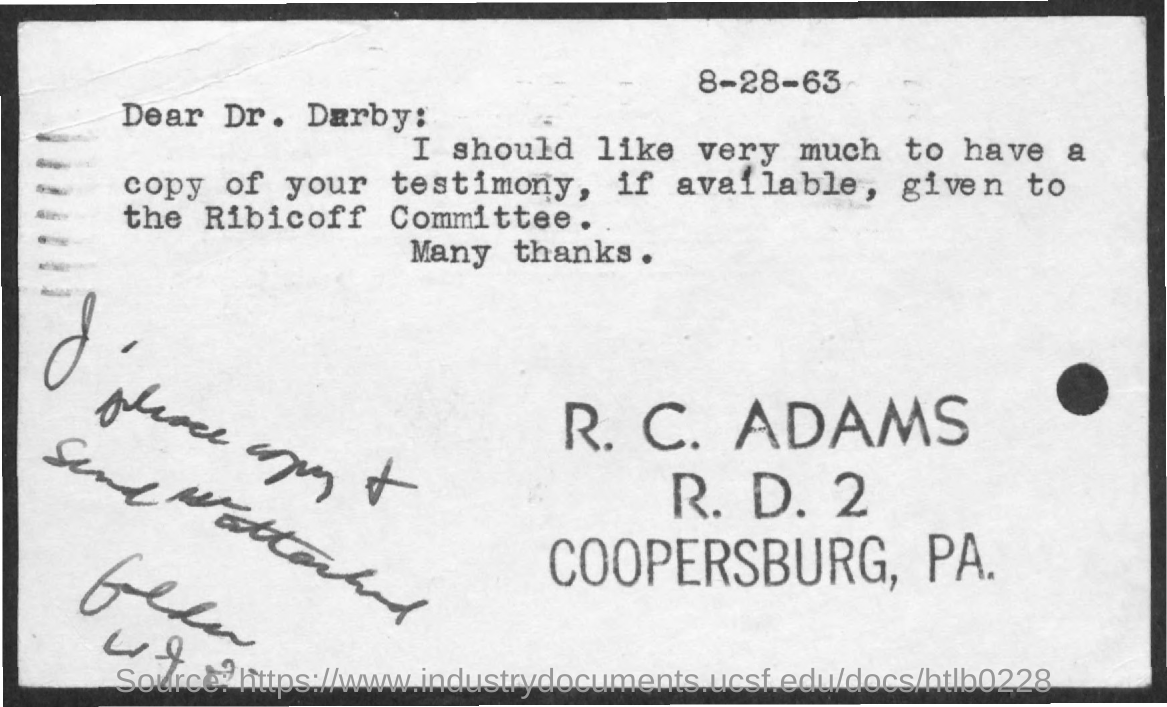Highlight a few significant elements in this photo. The testimony should be given to the Ribicoff Committee. The letter is addressed to Dr. Darby. The date mentioned is 8-28-63. The sender of the letter is R. C. Adams. 